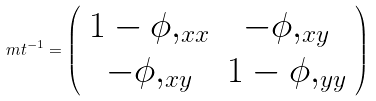Convert formula to latex. <formula><loc_0><loc_0><loc_500><loc_500>\ m t ^ { - 1 } = \left ( \begin{array} { c c } 1 - \phi , _ { x x } & - \phi , _ { x y } \\ - \phi , _ { x y } & 1 - \phi , _ { y y } \end{array} \right )</formula> 